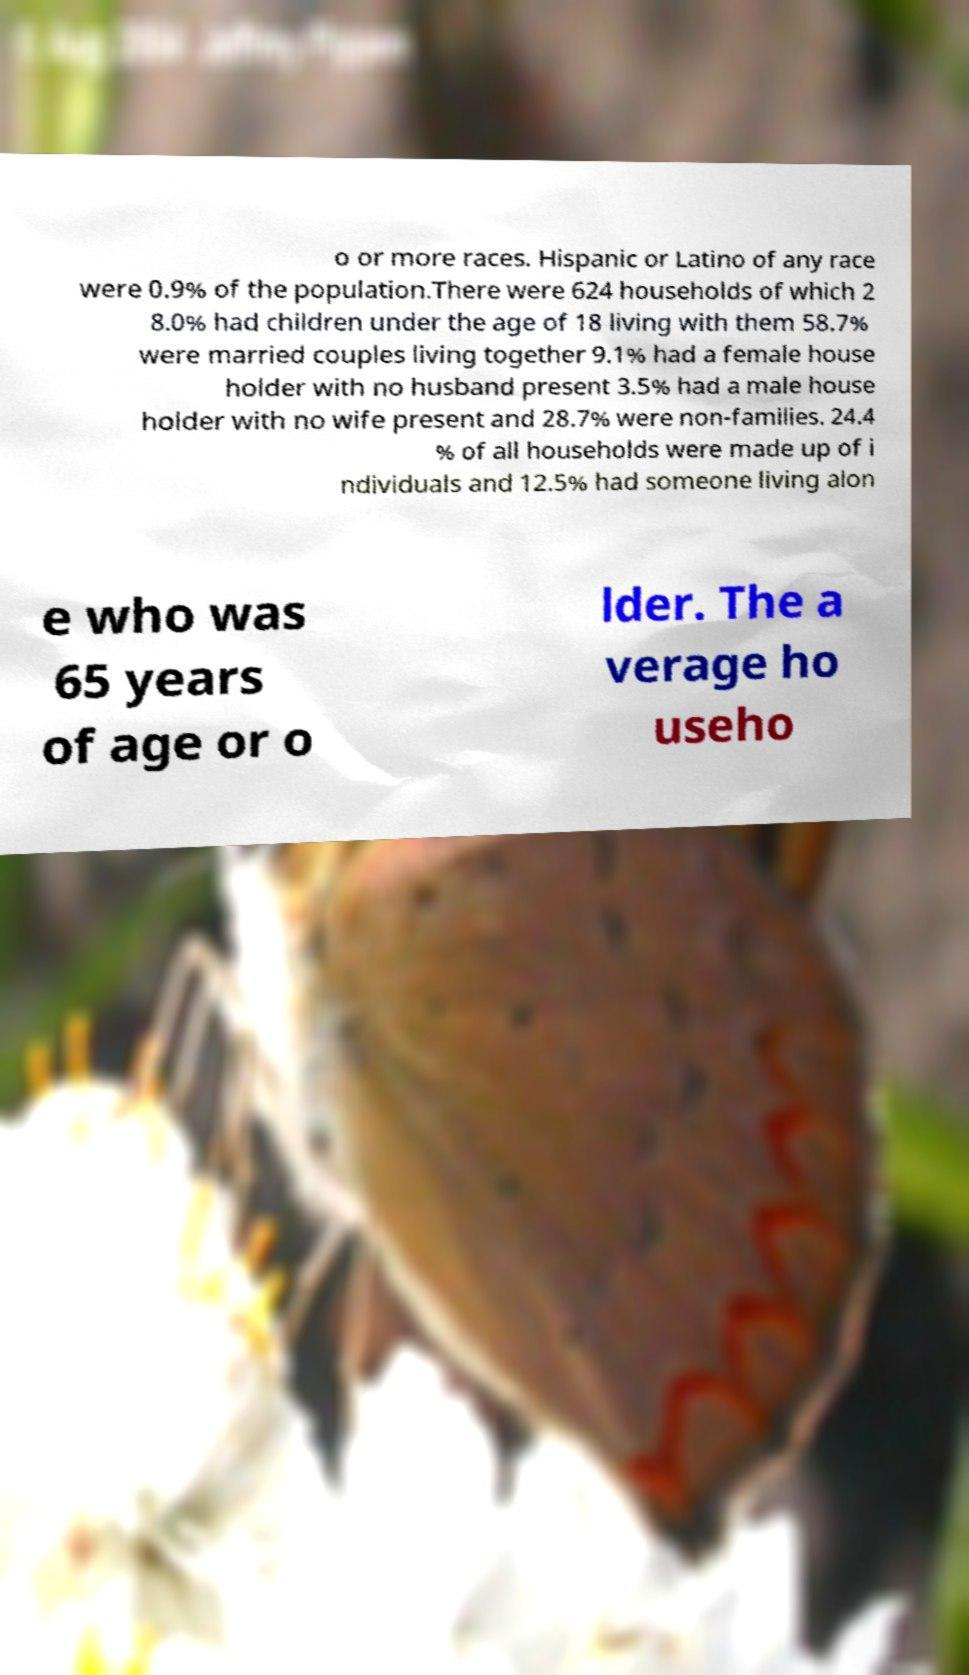For documentation purposes, I need the text within this image transcribed. Could you provide that? o or more races. Hispanic or Latino of any race were 0.9% of the population.There were 624 households of which 2 8.0% had children under the age of 18 living with them 58.7% were married couples living together 9.1% had a female house holder with no husband present 3.5% had a male house holder with no wife present and 28.7% were non-families. 24.4 % of all households were made up of i ndividuals and 12.5% had someone living alon e who was 65 years of age or o lder. The a verage ho useho 